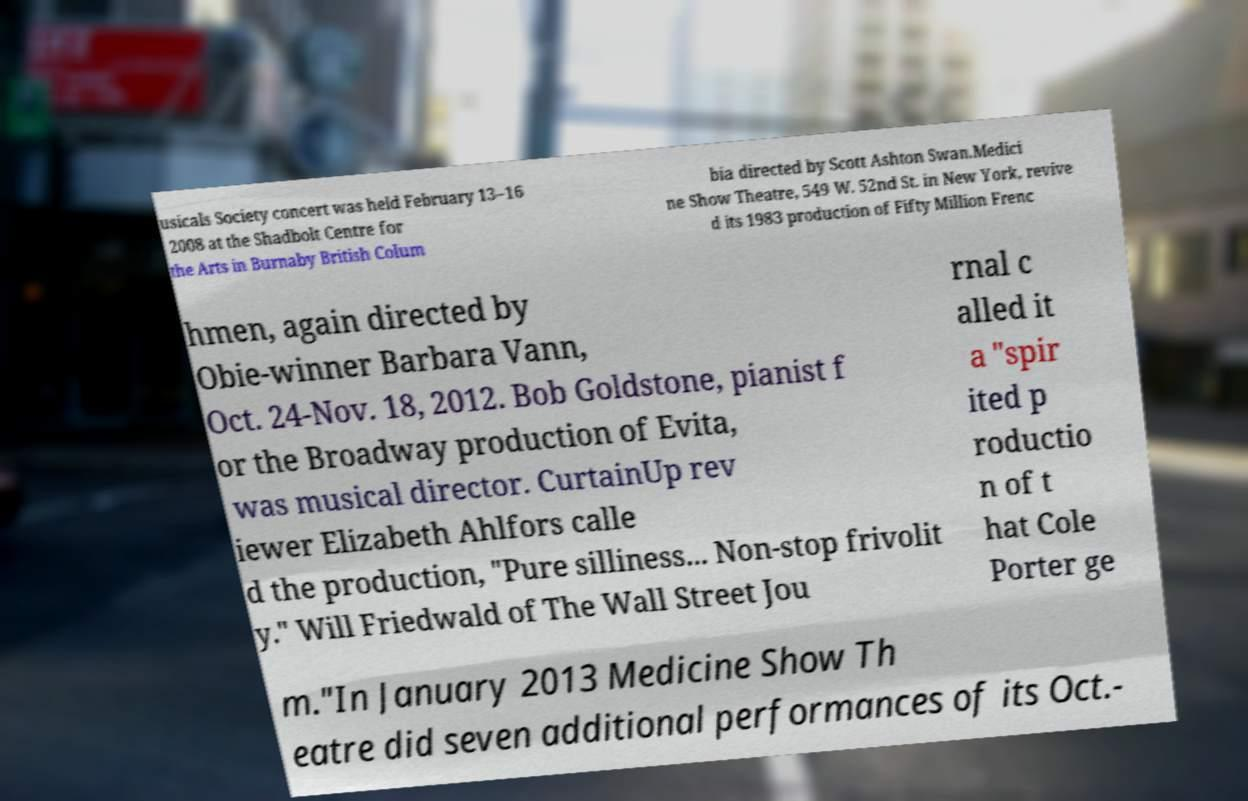I need the written content from this picture converted into text. Can you do that? usicals Society concert was held February 13–16 2008 at the Shadbolt Centre for the Arts in Burnaby British Colum bia directed by Scott Ashton Swan.Medici ne Show Theatre, 549 W. 52nd St. in New York, revive d its 1983 production of Fifty Million Frenc hmen, again directed by Obie-winner Barbara Vann, Oct. 24-Nov. 18, 2012. Bob Goldstone, pianist f or the Broadway production of Evita, was musical director. CurtainUp rev iewer Elizabeth Ahlfors calle d the production, "Pure silliness... Non-stop frivolit y." Will Friedwald of The Wall Street Jou rnal c alled it a "spir ited p roductio n of t hat Cole Porter ge m."In January 2013 Medicine Show Th eatre did seven additional performances of its Oct.- 